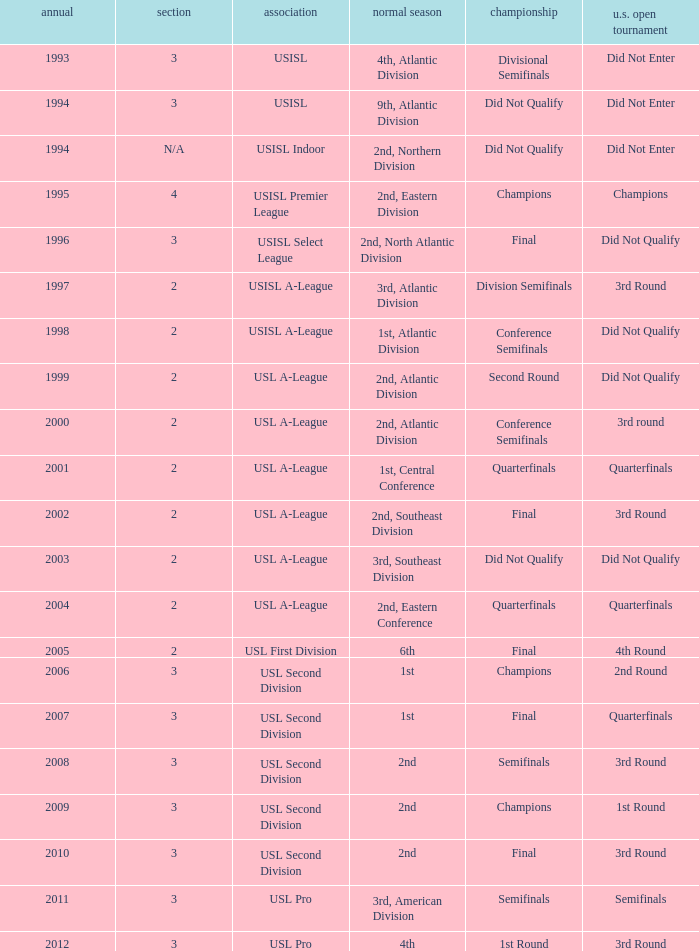What's the u.s. open cup status for regular season of 4th, atlantic division  Did Not Enter. 